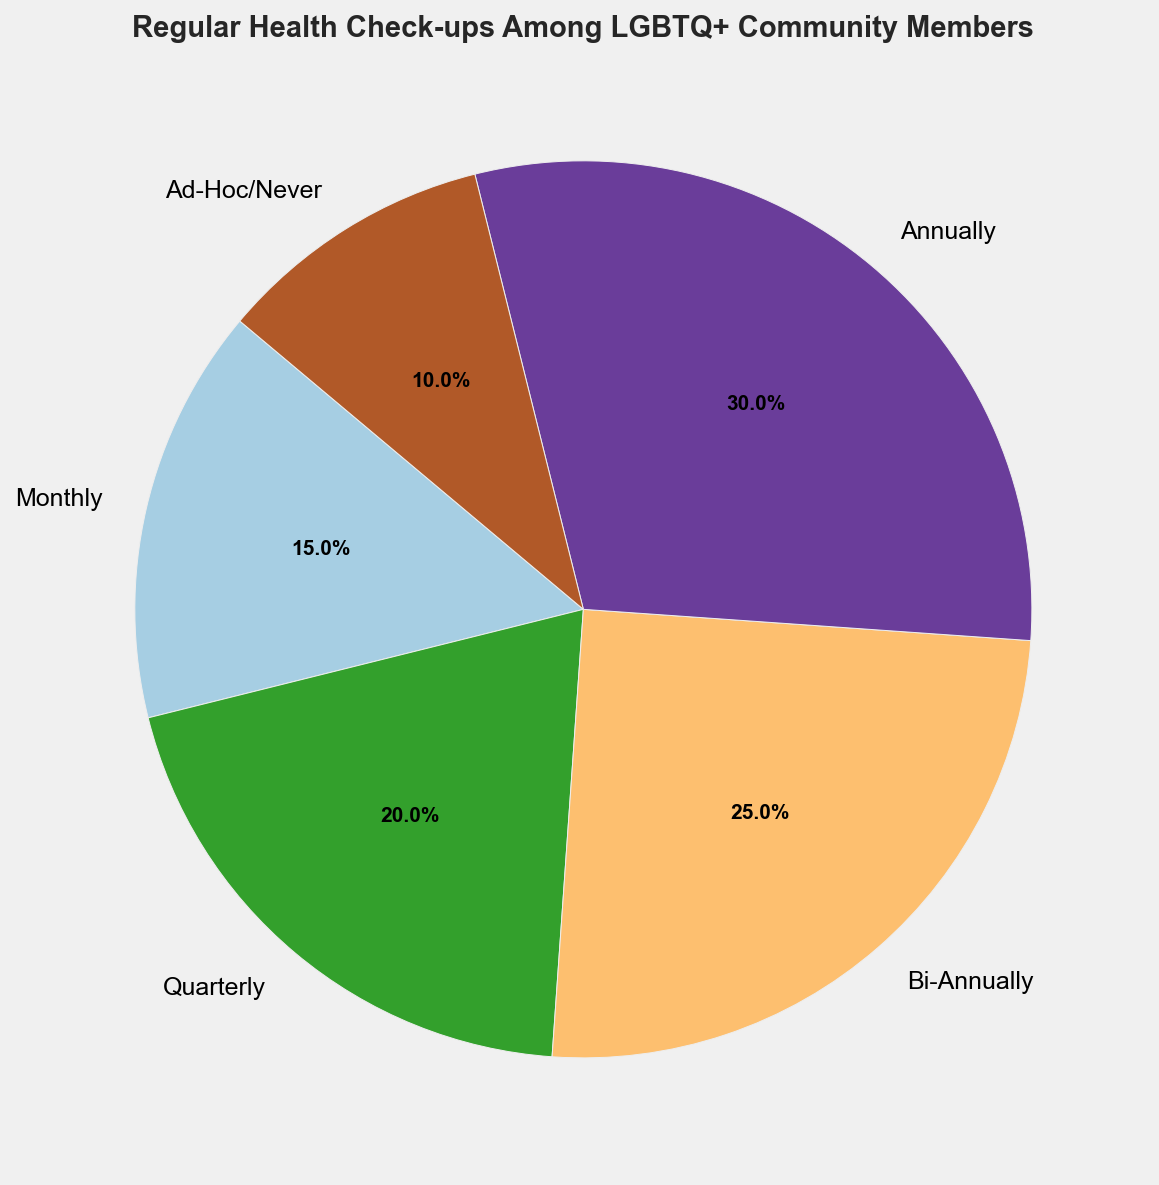What percentage of the LGBTQ+ community attends quarterly health check-ups? The slice labeled "Quarterly" in the pie chart represents the portion of the community that attends quarterly health check-ups. This is shown as 20%.
Answer: 20% Which frequency has the highest percentage of attendance? To determine the highest percentage, compare all the percentages in the pie chart. The "Annually" slice has the highest percentage at 30%.
Answer: Annually What is the combined percentage of those who attend either monthly or quarterly check-ups? This requires adding the percentages for "Monthly" and "Quarterly". Monthly is 15% and Quarterly is 20%, so the total is 15% + 20% = 35%.
Answer: 35% Is the percentage of those attending bi-annually greater than those attending ad-hoc or never? Compare the slices "Bi-Annually" and "Ad-Hoc/Never". Bi-Annually is 25%, and Ad-Hoc/Never is 10%, so 25% > 10%.
Answer: Yes What fractions of the pie are made up by Quarterly and Bi-Annually combined? The question asks for the sum of the percentages of the "Quarterly" and "Bi-Annually" frequencies. Quarterly is 20% and Bi-Annually is 25%, so combined they are 20% + 25% = 45%.
Answer: 45% Which segment has a darker shade of color, Monthly or Annually? Visually, the pie chart uses different shades for each category. Compare "Monthly" and "Annually" slices — "Annually" typically has a darker shade due to its position in the color scale.
Answer: Annually How does the percentage of monthly check-ups compare to bi-annual check-ups? Compare the "Monthly" slice at 15% to the "Bi-Annually" slice at 25%. Monthly is less than Bi-Annually.
Answer: Monthly is less than Bi-Annually What is the visual significance of the Ad-Hoc/Never category? The "Ad-Hoc/Never" slice is the smallest in the pie chart, indicating it has the lowest percentage at 10%.
Answer: It indicates the lowest percentage at 10% Calculate the average percentage of attending health check-ups across all given frequencies. Sum all percentages (15%+20%+25%+30%+10% = 100%) and divide by the number of frequencies, which is 5. The average is 100% / 5 = 20%.
Answer: 20% Is there any category that has double the percentage of another category? Check multiples of percentages. The "Annually" category has 30%, which is double the 15% of the "Monthly" category.
Answer: Yes, Annually is double Monthly 